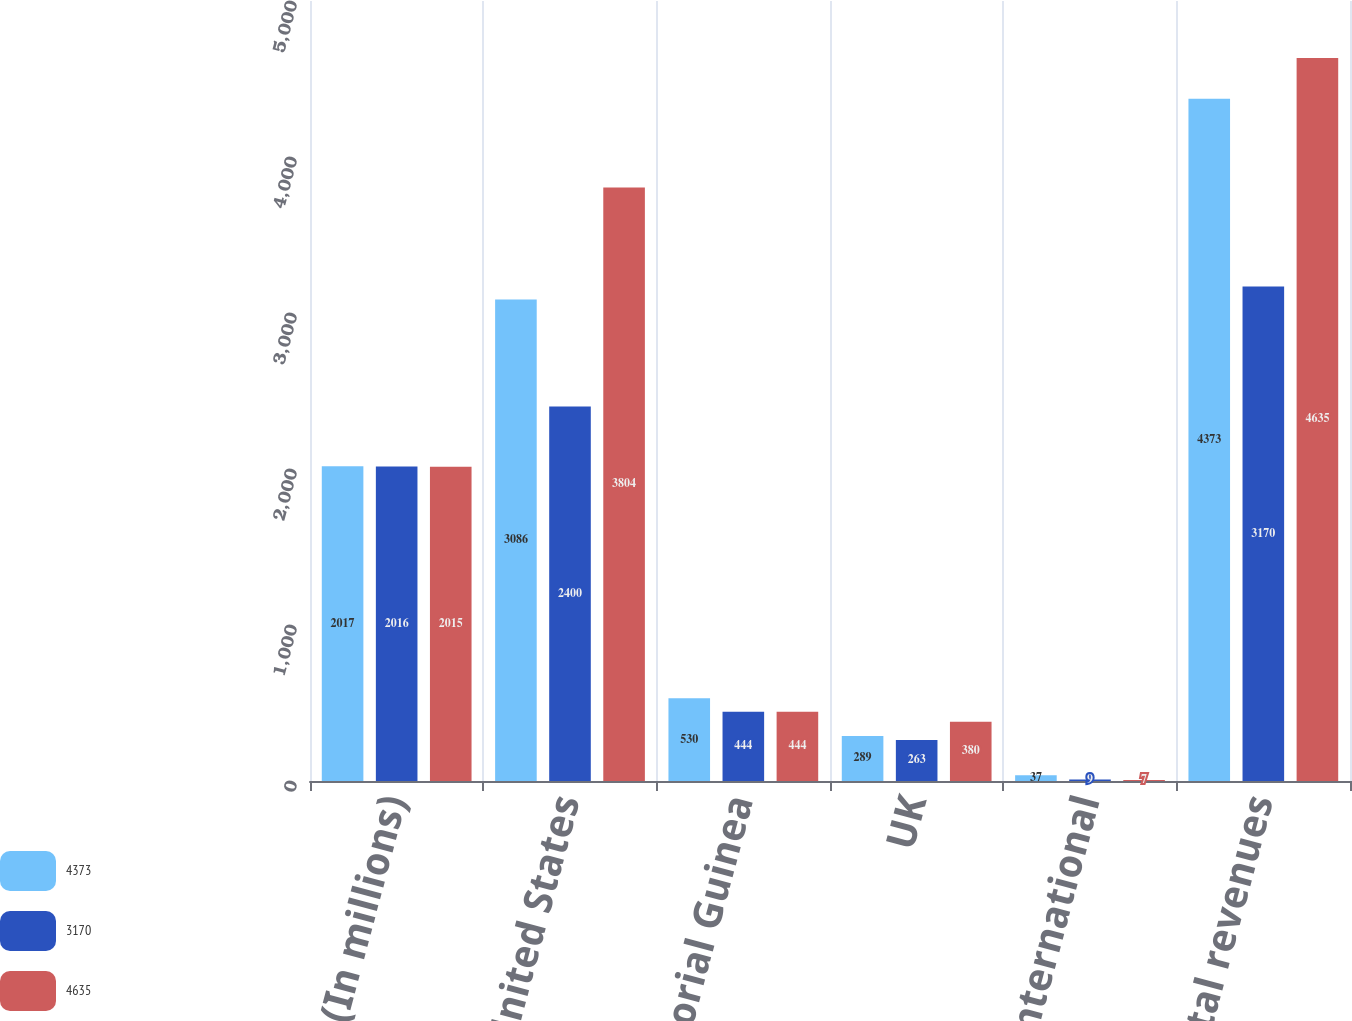<chart> <loc_0><loc_0><loc_500><loc_500><stacked_bar_chart><ecel><fcel>(In millions)<fcel>United States<fcel>Equatorial Guinea<fcel>UK<fcel>Other international<fcel>Total revenues<nl><fcel>4373<fcel>2017<fcel>3086<fcel>530<fcel>289<fcel>37<fcel>4373<nl><fcel>3170<fcel>2016<fcel>2400<fcel>444<fcel>263<fcel>9<fcel>3170<nl><fcel>4635<fcel>2015<fcel>3804<fcel>444<fcel>380<fcel>7<fcel>4635<nl></chart> 